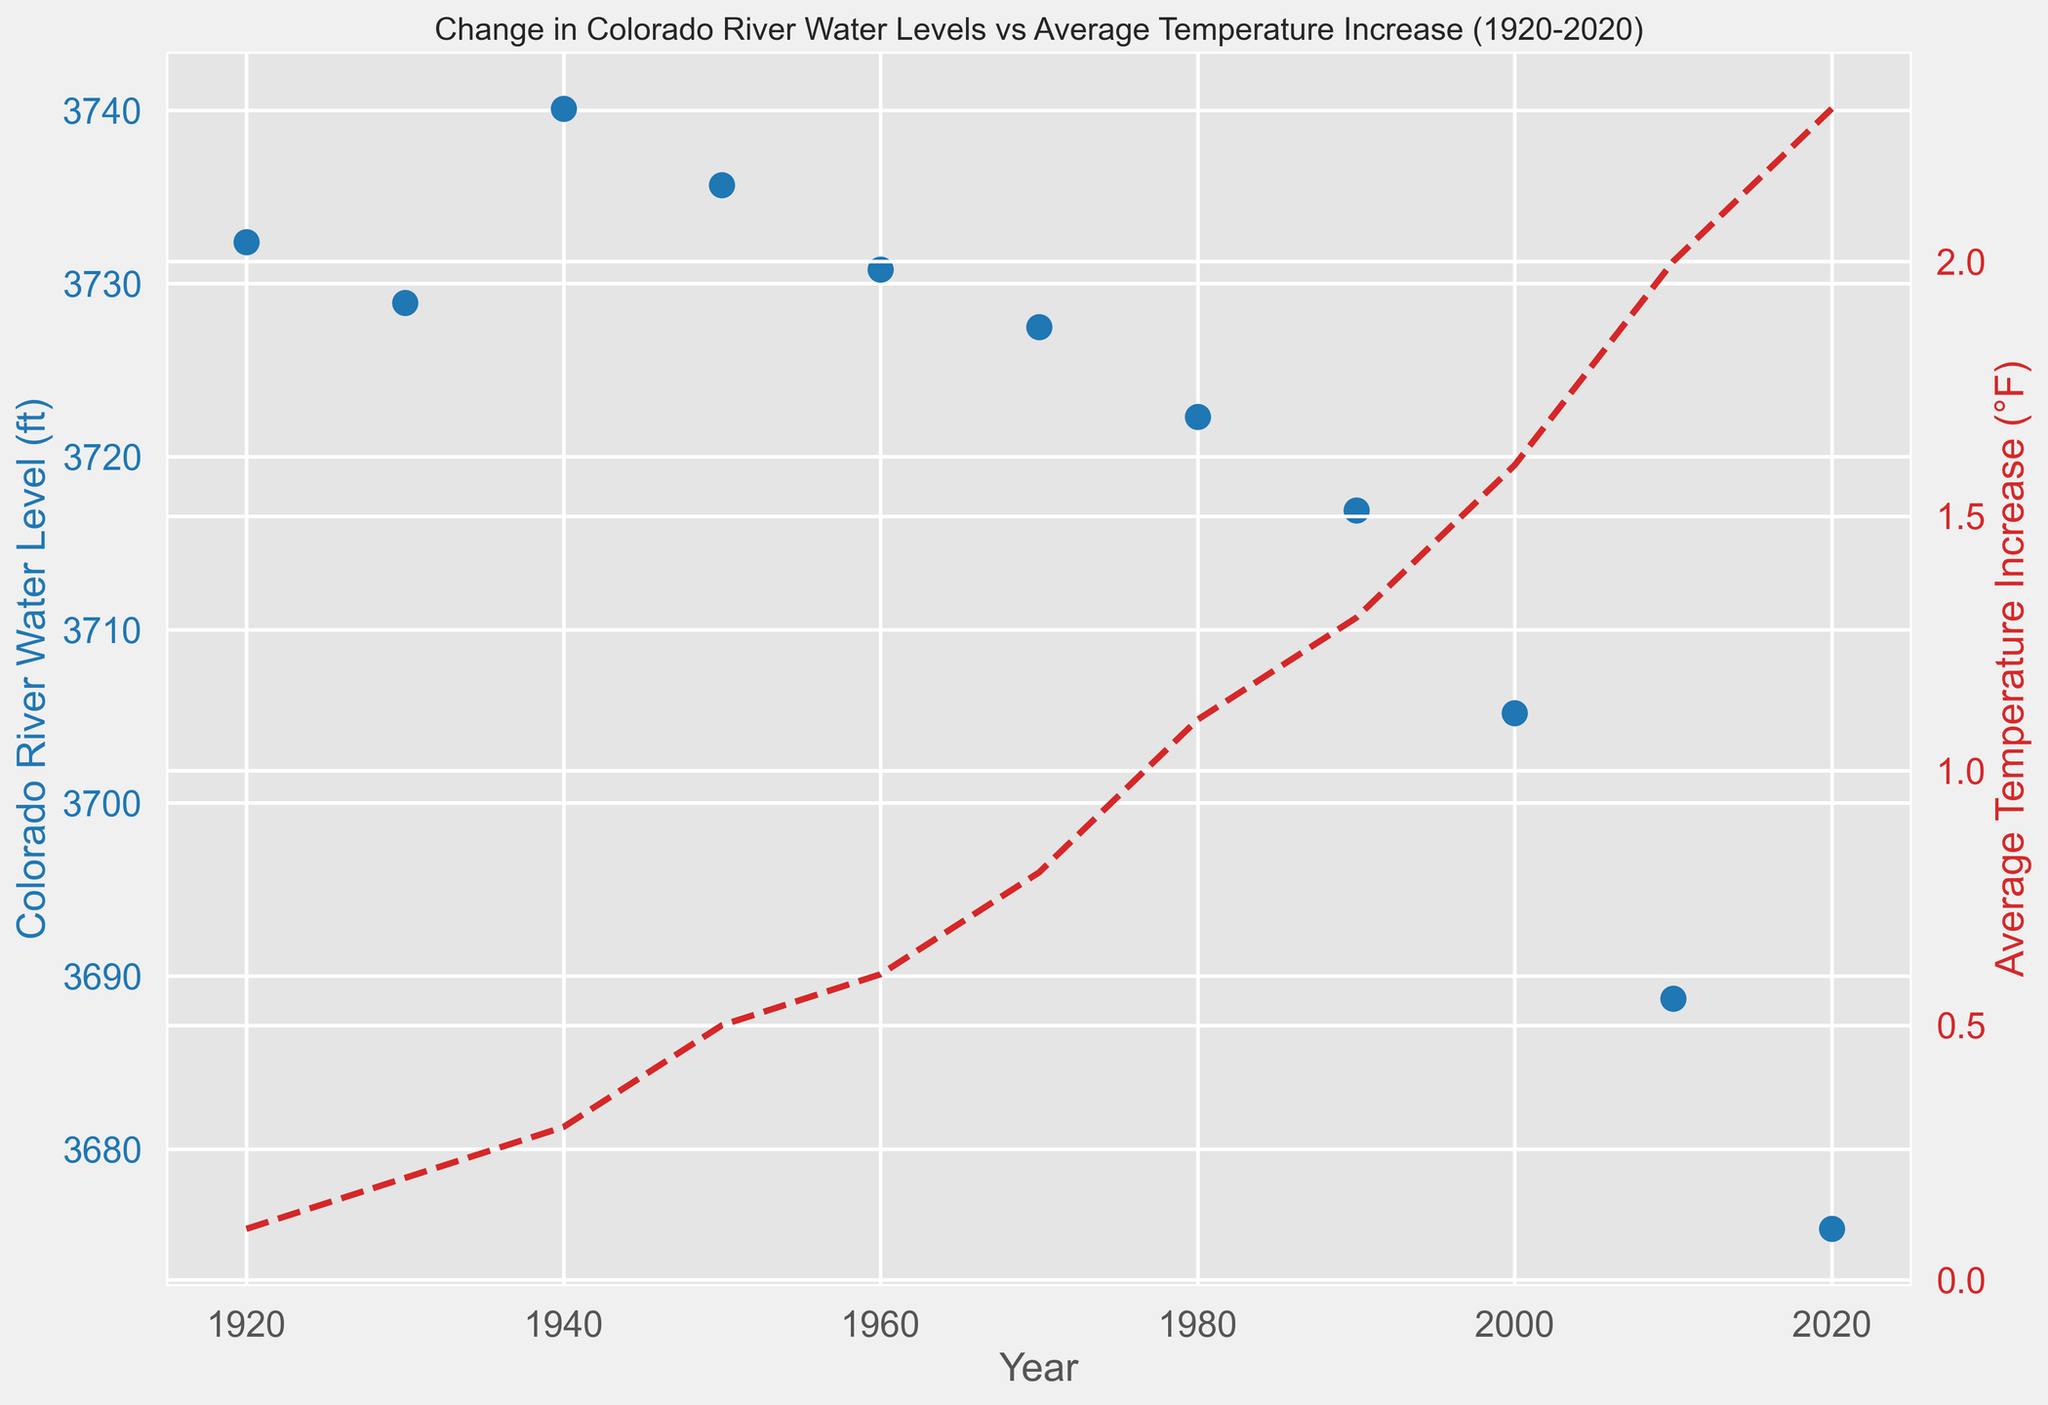What is the general trend in the Colorado River water levels from 1920 to 2020? The water levels generally decrease over the century, with the highest level in 1940 and a declining trend thereafter.
Answer: Decreasing How has the average temperature increased from 1920 to 2020? The average temperature has steadily increased from 0.1°F in 1920 to 2.3°F in 2020.
Answer: Increasing Compare the Colorado River water level in 1940 to that in 2020. In 1940, the water level was 3740.1 ft, whereas in 2020 it dropped to 3675.4 ft.
Answer: 1940 > 2020 Is there a year where both the water level decreased significantly and the temperature increased significantly? Between 2000 and 2010, the water level decreased from 3705.2 ft to 3688.7 ft, and the temperature increased from 1.6°F to 2.0°F.
Answer: Yes, 2000 to 2010 What year had the highest Colorado River water level, and what was the temperature increase that year? The highest water level was in 1940 at 3740.1 ft, with a temperature increase of 0.3°F.
Answer: 1940, 0.3°F How much has the Colorado River water level dropped from 1920 to 2020? The water level dropped from 3732.4 ft in 1920 to 3675.4 ft in 2020. To find the drop: 3732.4 - 3675.4 = 57 ft.
Answer: 57 ft What is the average temperature increase over the decades shown in the figure? The sum of the temperature increase values (0.1 + 0.2 + 0.3 + 0.5 + 0.6 + 0.8 + 1.1 + 1.3 + 1.6 + 2.0 + 2.3) is 10.8. Divide by the number of decades: 10.8 / 11 ≈ 0.98°F.
Answer: 0.98°F 